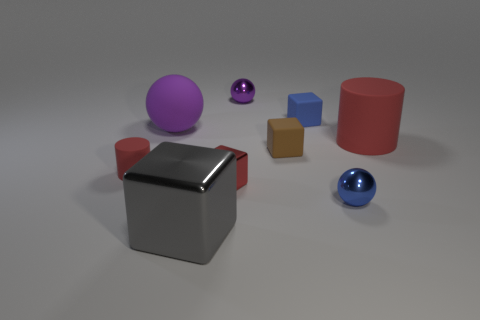Do the big rubber sphere and the matte cylinder that is to the right of the large ball have the same color?
Your answer should be very brief. No. There is a red matte thing that is on the left side of the gray metallic cube; what shape is it?
Ensure brevity in your answer.  Cylinder. How many other things are there of the same material as the big red cylinder?
Make the answer very short. 4. What is the material of the tiny red block?
Offer a terse response. Metal. What number of large objects are either purple shiny objects or purple spheres?
Your answer should be very brief. 1. There is a tiny red block; how many small things are to the left of it?
Give a very brief answer. 1. Is there a big object of the same color as the big matte cylinder?
Provide a short and direct response. No. What is the shape of the red object that is the same size as the purple matte object?
Make the answer very short. Cylinder. What number of brown things are either matte balls or spheres?
Your answer should be very brief. 0. How many red cylinders are the same size as the blue sphere?
Offer a very short reply. 1. 